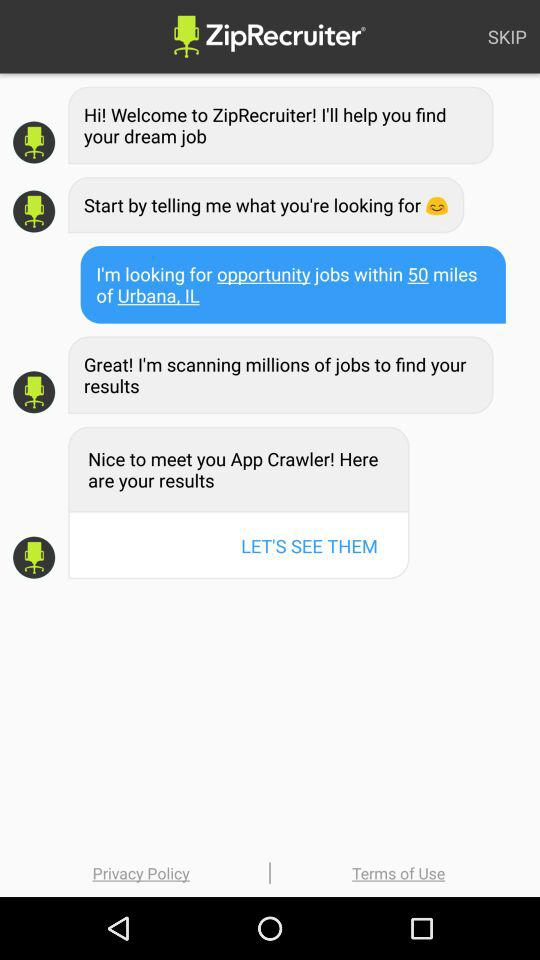Within how many miles do you need job openings? You need job openings within 50 miles. 